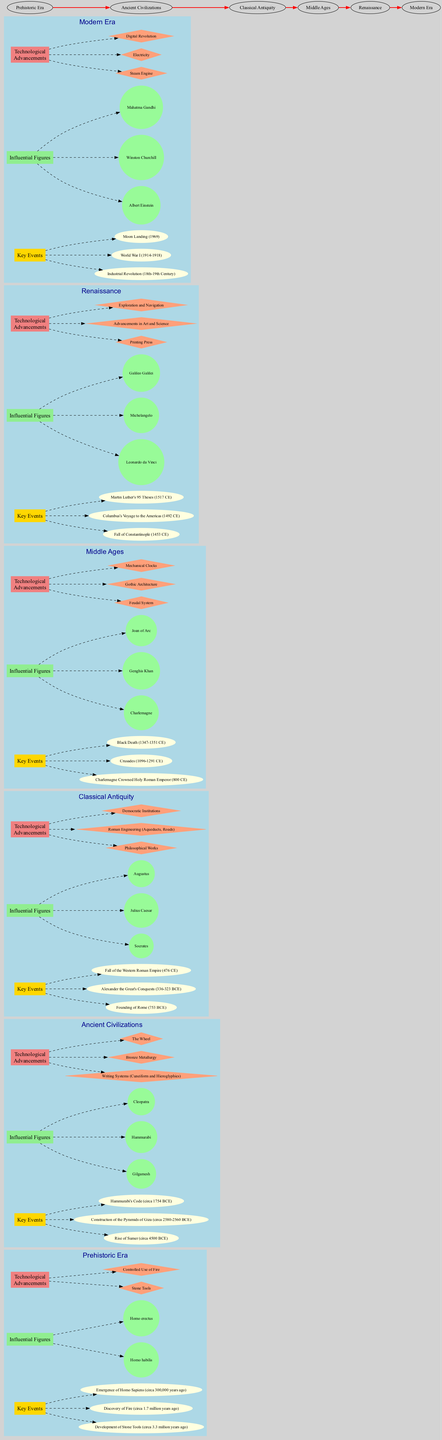What are the key events in the Prehistoric Era? The key events are listed under the Prehistoric Era section of the diagram. They are: Development of Stone Tools, Discovery of Fire, and Emergence of Homo Sapiens.
Answer: Development of Stone Tools, Discovery of Fire, Emergence of Homo Sapiens Who was an influential figure during the Ancient Civilizations? The influential figures for Ancient Civilizations are grouped within that section. One of them is Hammurabi, whose name is directly connected to that time period.
Answer: Hammurabi How many technological advancements are listed in the Classical Antiquity? To find this, one needs to count the items listed under the technological advancements within the Classical Antiquity cluster. There are three items listed: Philosophical Works, Roman Engineering, and Democratic Institutions.
Answer: 3 What connects the Renaissance to the Middle Ages? The connection between Renaissance and Middle Ages is indicated on the diagram through a bold edge that signifies chronological progression. The arrow points from the Middle Ages to the Renaissance.
Answer: A bold edge Which influential figure is associated with the Fall of Constantinople? The diagram does not list any influential figure specifically tied to the Fall of Constantinople; hence the figure associated with the Renaissance is Leonardo da Vinci found in that cluster.
Answer: Leonardo da Vinci Identify one key event from the Modern Era. The Modern Era showcases several key events, one of which is the Moon Landing; this can be directly referenced from the key events under that cluster in the diagram.
Answer: Moon Landing What is the last technological advancement mentioned? The last technological advancement can be identified by checking the list under the Modern Era. The last item listed is Digital Revolution.
Answer: Digital Revolution Which period has the most key events listed? To determine this, one must compare the number of key events listed in each period. The Ancient Civilizations have three key events, and so do the Middle Ages. Both of these periods have the highest count when compared to the others.
Answer: Ancient Civilizations and Middle Ages (each with 3 events) 